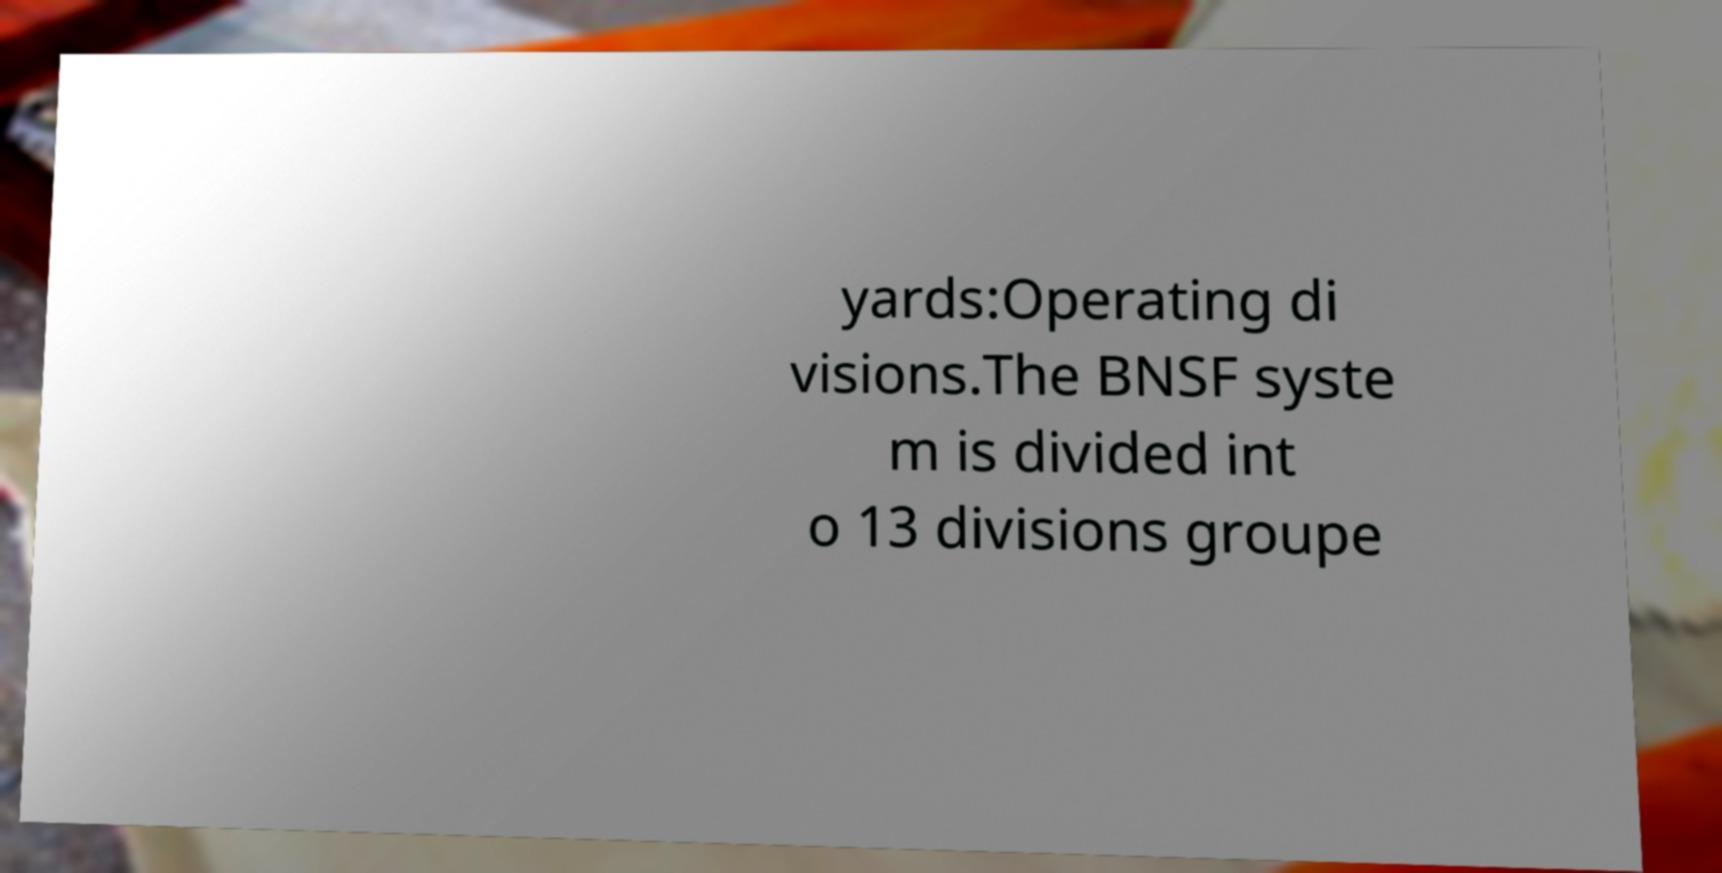There's text embedded in this image that I need extracted. Can you transcribe it verbatim? yards:Operating di visions.The BNSF syste m is divided int o 13 divisions groupe 